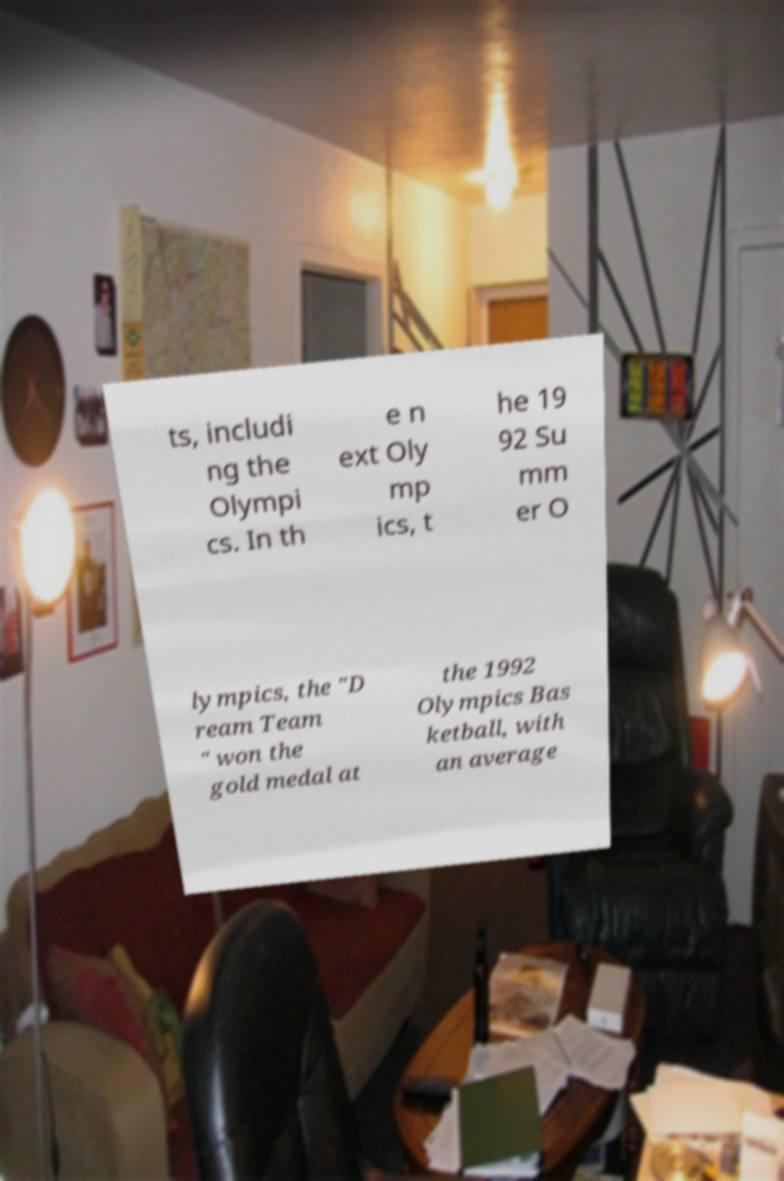Please identify and transcribe the text found in this image. ts, includi ng the Olympi cs. In th e n ext Oly mp ics, t he 19 92 Su mm er O lympics, the "D ream Team " won the gold medal at the 1992 Olympics Bas ketball, with an average 